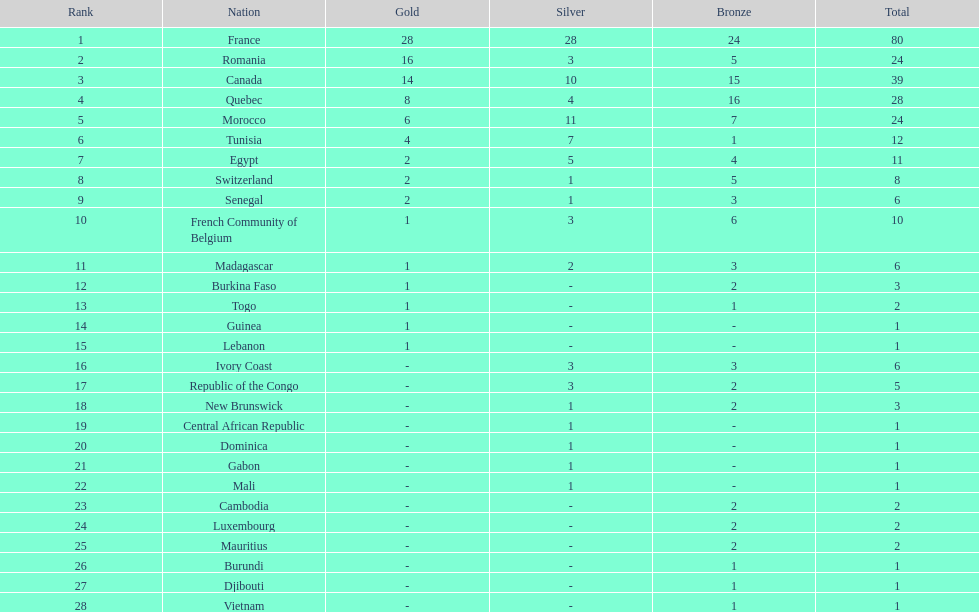How many counties have at least one silver medal? 18. 